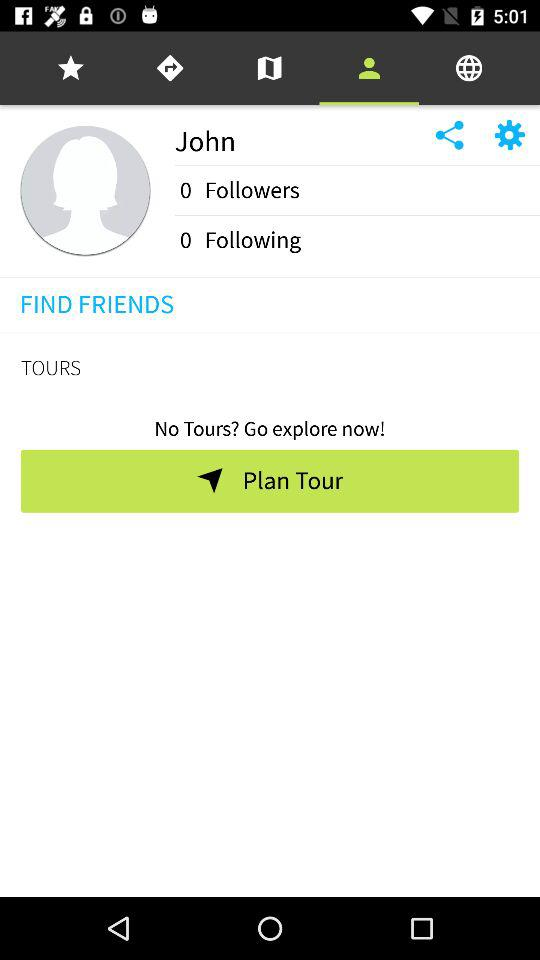How many people is John following? John is following 0 people. 